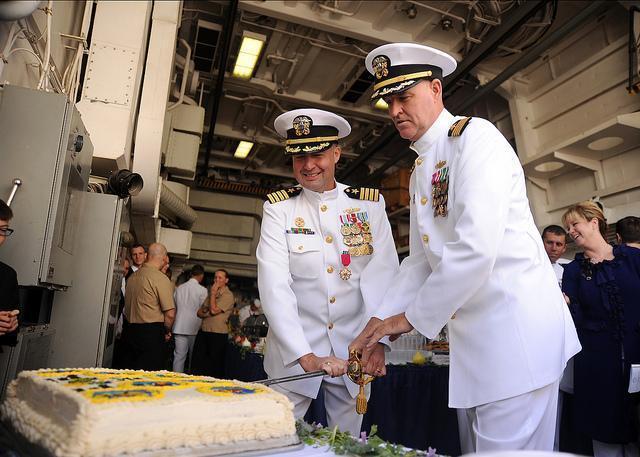How many people are in the picture?
Give a very brief answer. 6. 